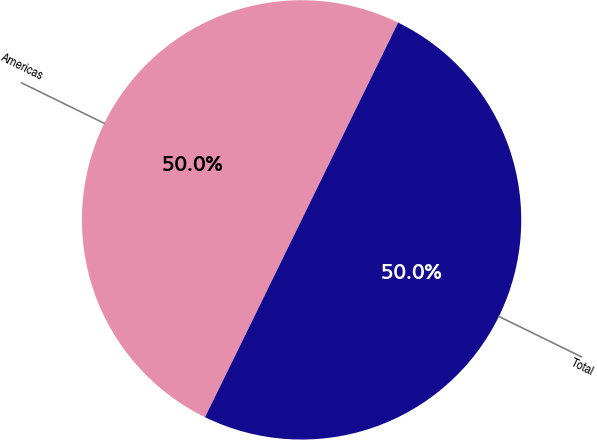Convert chart to OTSL. <chart><loc_0><loc_0><loc_500><loc_500><pie_chart><fcel>Americas<fcel>Total<nl><fcel>50.0%<fcel>50.0%<nl></chart> 